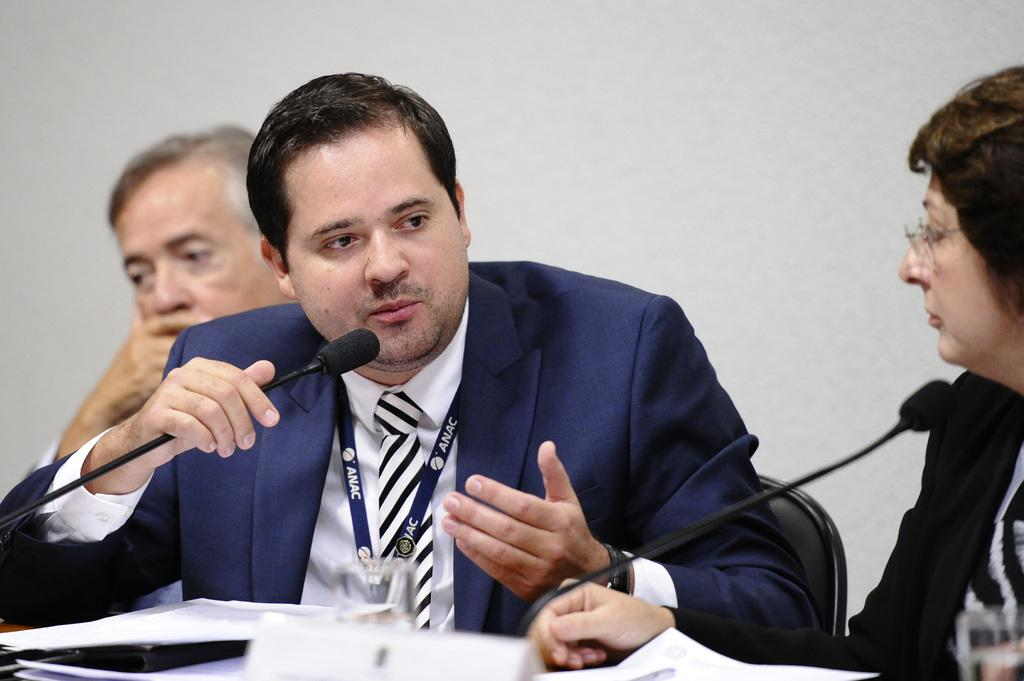How many people are in the image? There are three persons in the image. What are the persons doing in the image? The persons are sitting on chairs in front of a table. What is on the table? There is a glass and papers on the table. What is one person holding? One person is holding a microphone. What is the person holding the microphone doing? The person holding the microphone is talking. Can you see any clover growing on the table in the image? There is no clover present on the table in the image. Is there any snow visible in the image? There is no snow visible in the image. 